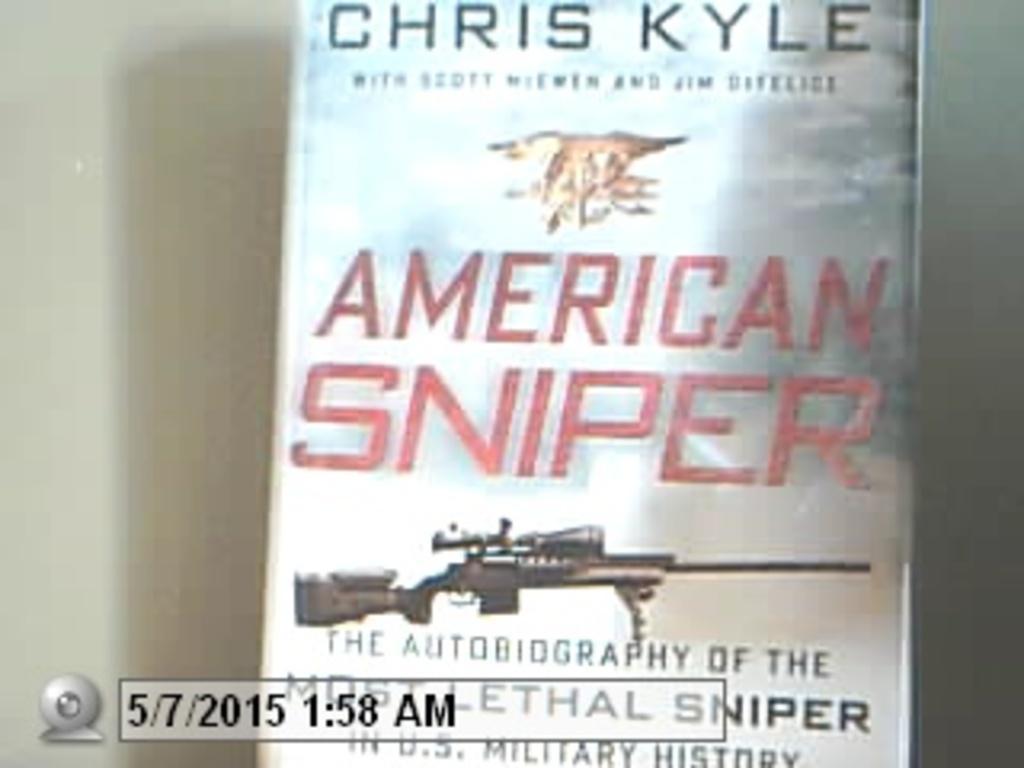In one or two sentences, can you explain what this image depicts? In this image we can see a book with a picture of a gun and some text on it. 